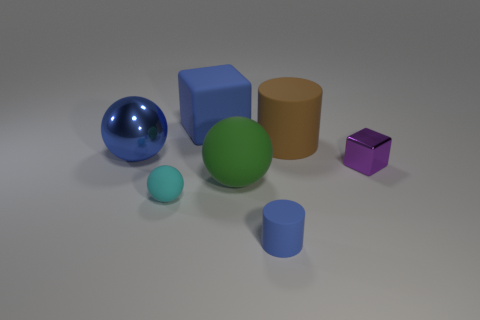Add 1 tiny purple blocks. How many objects exist? 8 Subtract all large balls. How many balls are left? 1 Subtract 1 balls. How many balls are left? 2 Add 3 big gray matte cylinders. How many big gray matte cylinders exist? 3 Subtract all blue cylinders. How many cylinders are left? 1 Subtract 0 gray spheres. How many objects are left? 7 Subtract all blocks. How many objects are left? 5 Subtract all cyan cubes. Subtract all purple balls. How many cubes are left? 2 Subtract all large brown rubber things. Subtract all large blue rubber objects. How many objects are left? 5 Add 7 large blue rubber blocks. How many large blue rubber blocks are left? 8 